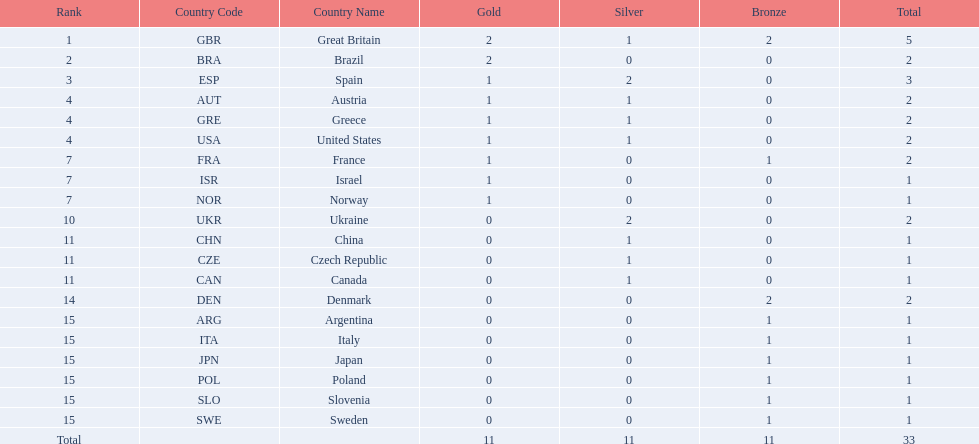How many medals did spain gain 3. Only country that got more medals? Spain (ESP). 